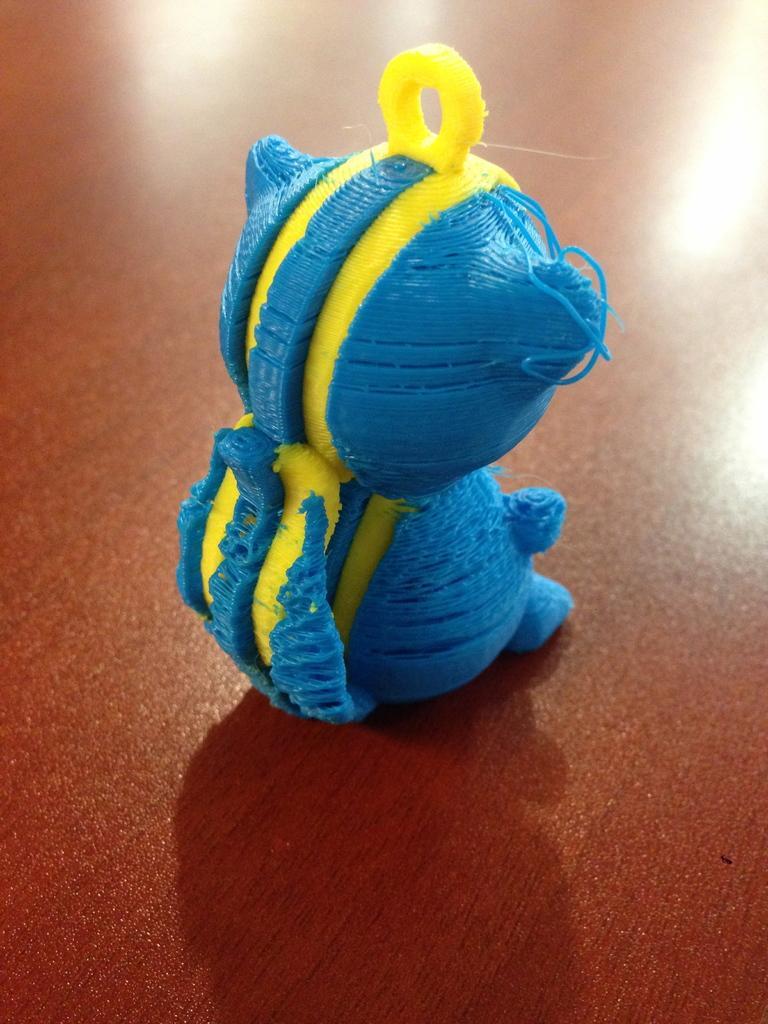In one or two sentences, can you explain what this image depicts? In the image we can see there is a toy kept on the table. 